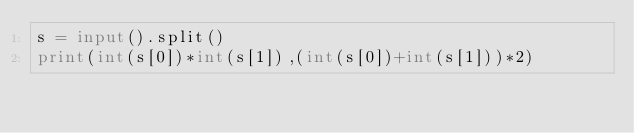<code> <loc_0><loc_0><loc_500><loc_500><_Python_>s = input().split()
print(int(s[0])*int(s[1]),(int(s[0])+int(s[1]))*2)
</code> 